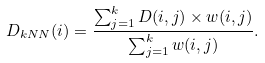Convert formula to latex. <formula><loc_0><loc_0><loc_500><loc_500>D _ { k N N } ( i ) = \frac { \sum _ { j = 1 } ^ { k } D ( i , j ) \times w ( i , j ) } { \sum _ { j = 1 } ^ { k } w ( i , j ) } .</formula> 